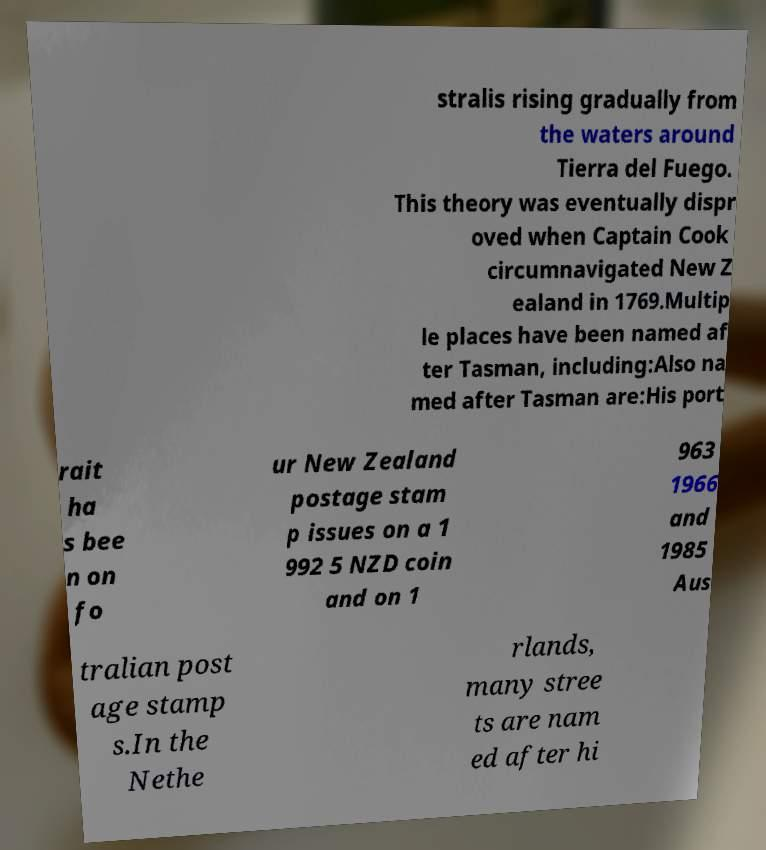Please read and relay the text visible in this image. What does it say? stralis rising gradually from the waters around Tierra del Fuego. This theory was eventually dispr oved when Captain Cook circumnavigated New Z ealand in 1769.Multip le places have been named af ter Tasman, including:Also na med after Tasman are:His port rait ha s bee n on fo ur New Zealand postage stam p issues on a 1 992 5 NZD coin and on 1 963 1966 and 1985 Aus tralian post age stamp s.In the Nethe rlands, many stree ts are nam ed after hi 